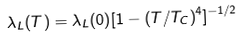<formula> <loc_0><loc_0><loc_500><loc_500>\lambda _ { L } ( T ) = \lambda _ { L } ( 0 ) [ 1 - ( T / T _ { C } ) ^ { 4 } ] ^ { - 1 / 2 }</formula> 